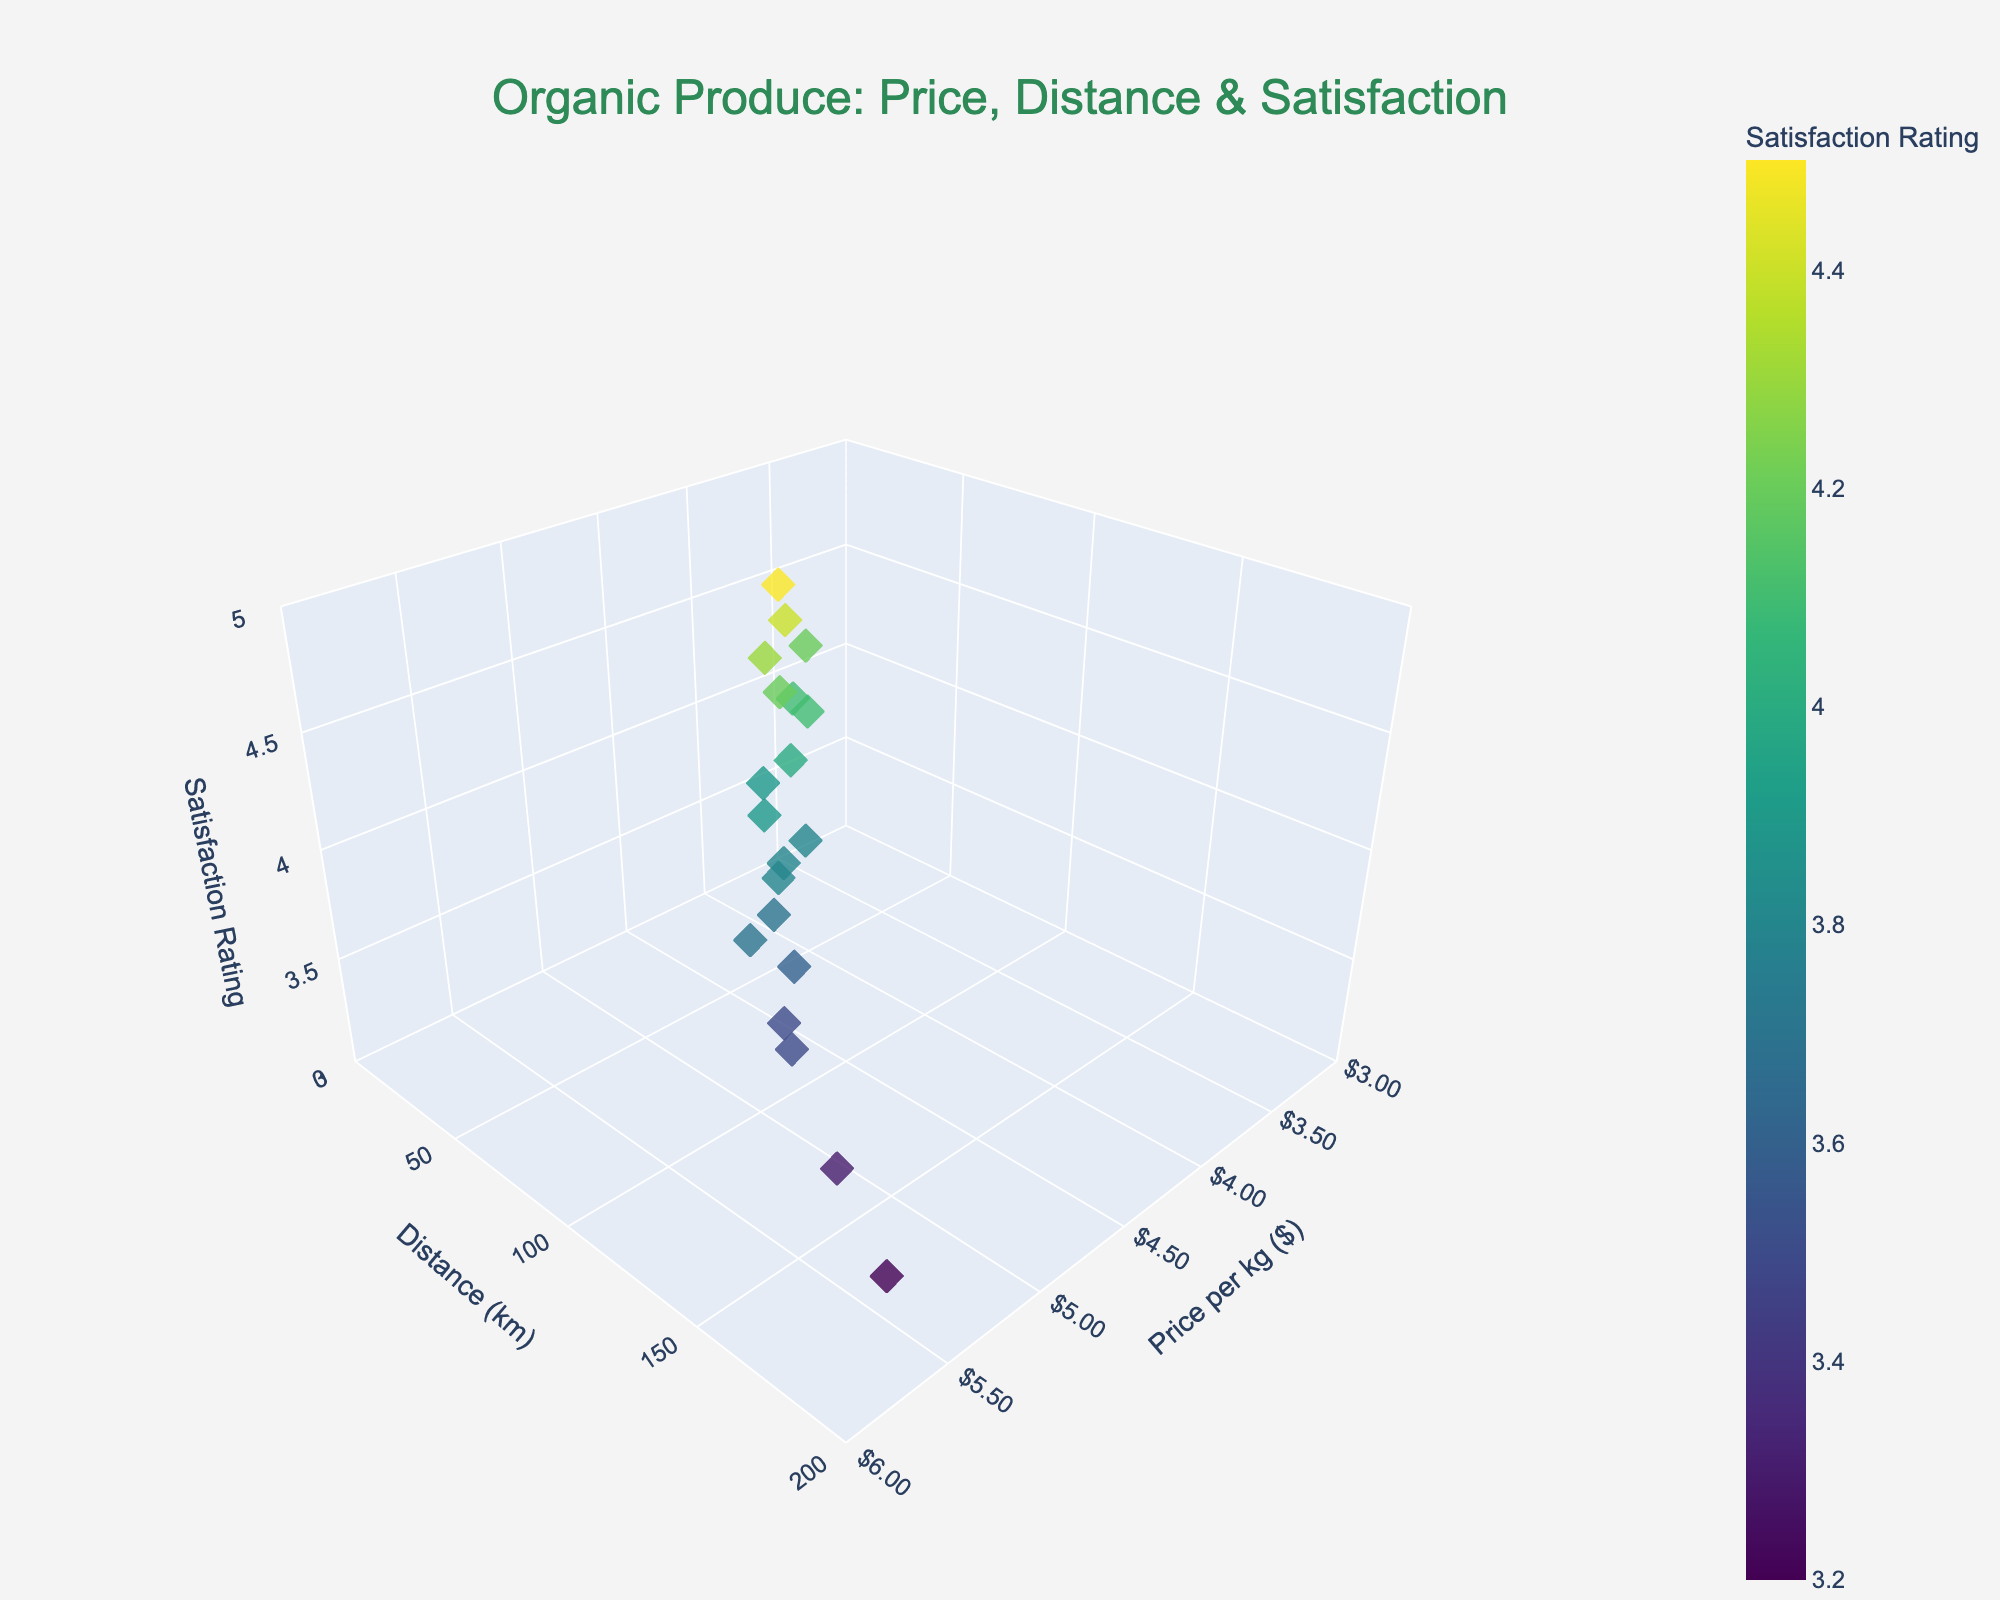what is the range for the satisfaction rating axis? The z-axis represents the satisfaction rating, and it ranges from 3 to 5 according to the created axis labels and limits.
Answer: 3 to 5 How many data points are represented in the figure? By closely examining the figure, we can observe 20 individual markers representing the data points.
Answer: 20 Identify the data point with the highest price per kg and state its satisfaction rating. The highest price per kg shown on the x-axis is $5.50, and the corresponding satisfaction rating for this data point is 3.2, as determined from the tooltip or visual inspection.
Answer: 3.2 Do satisfaction ratings generally increase or decrease with larger transportation distances? By observing the z-axis values in relation to the y-axis values, it can be seen that satisfaction ratings tend to decrease as the transportation distance increases.
Answer: Decrease Which customer satisfaction rating appears most frequently? By analyzing the concentration of points along the z-axis, the satisfaction rating of 3.8 appears repeatedly among different distances and prices, indicating it's a common rating.
Answer: 3.8 Is there a clear correlation between price per kg and satisfaction rating? Examining the distribution of points along the x and z axes, there isn’t a strong and clear correlation between price per kg and satisfaction rating since ratings vary widely for different prices.
Answer: No What is the satisfaction rating for the shortest transportation distance recorded? The shortest transportation distance on the y-axis is 10 km, and its corresponding satisfaction rating is 4.5
Answer: 4.5 Between the data points with prices $4.80 and $3.70, which one has the higher satisfaction rating? The points with prices $4.80 and $3.70 have satisfaction ratings of 3.6 and 4.4, respectively. Therefore, the point with $3.70 has the higher rating.
Answer: $3.70 How many points have a transportation distance greater than 100 km? By counting the markers that are located beyond 100 km on the y-axis, we find there are 5 such points.
Answer: 5 What is the average price per kg for the data points with a satisfaction rating of 3.8? The points with a satisfaction rating of 3.8 have prices of $4.60, $4.30, and $4.50. Calculating the average: (4.60 + 4.30 + 4.50) / 3 = $4.47.
Answer: $4.47 